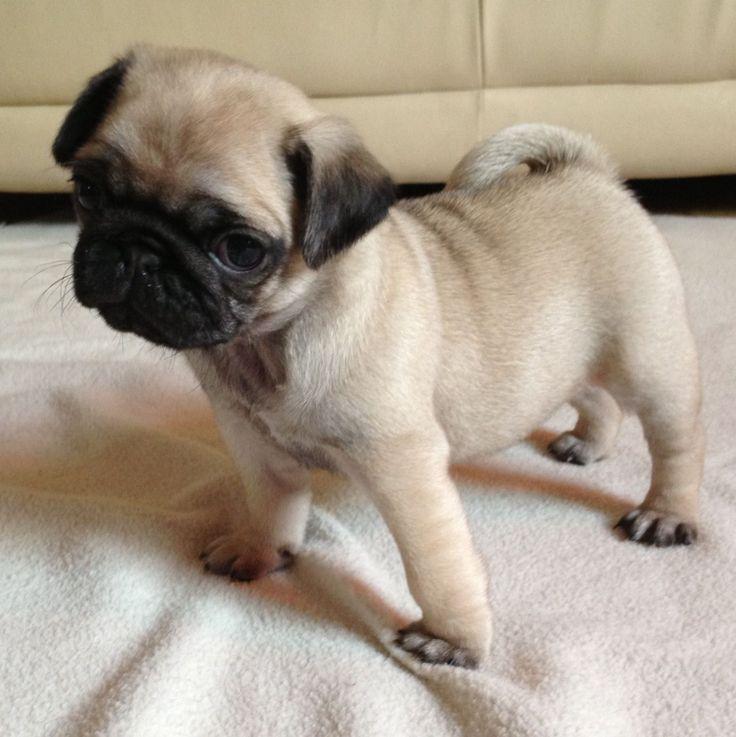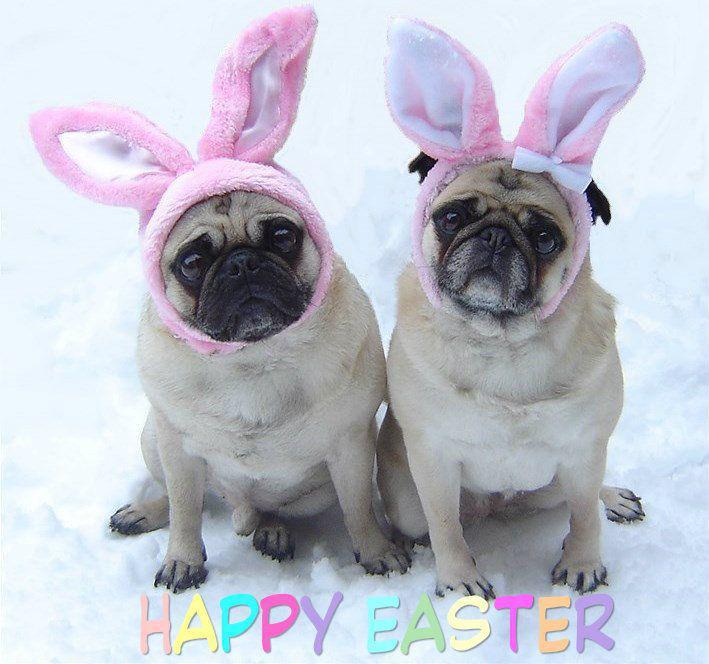The first image is the image on the left, the second image is the image on the right. Considering the images on both sides, is "At least one of the pugs is wearing something on its head." valid? Answer yes or no. Yes. The first image is the image on the left, the second image is the image on the right. Evaluate the accuracy of this statement regarding the images: "There is a pug wearing something decorative and cute on his head.". Is it true? Answer yes or no. Yes. 